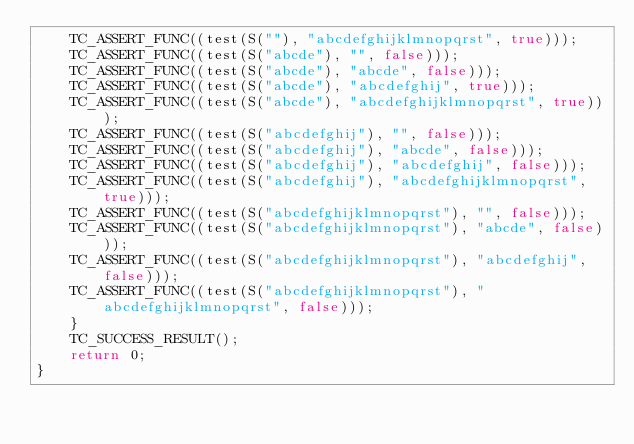<code> <loc_0><loc_0><loc_500><loc_500><_C++_>    TC_ASSERT_FUNC((test(S(""), "abcdefghijklmnopqrst", true)));
    TC_ASSERT_FUNC((test(S("abcde"), "", false)));
    TC_ASSERT_FUNC((test(S("abcde"), "abcde", false)));
    TC_ASSERT_FUNC((test(S("abcde"), "abcdefghij", true)));
    TC_ASSERT_FUNC((test(S("abcde"), "abcdefghijklmnopqrst", true)));
    TC_ASSERT_FUNC((test(S("abcdefghij"), "", false)));
    TC_ASSERT_FUNC((test(S("abcdefghij"), "abcde", false)));
    TC_ASSERT_FUNC((test(S("abcdefghij"), "abcdefghij", false)));
    TC_ASSERT_FUNC((test(S("abcdefghij"), "abcdefghijklmnopqrst", true)));
    TC_ASSERT_FUNC((test(S("abcdefghijklmnopqrst"), "", false)));
    TC_ASSERT_FUNC((test(S("abcdefghijklmnopqrst"), "abcde", false)));
    TC_ASSERT_FUNC((test(S("abcdefghijklmnopqrst"), "abcdefghij", false)));
    TC_ASSERT_FUNC((test(S("abcdefghijklmnopqrst"), "abcdefghijklmnopqrst", false)));
    }
    TC_SUCCESS_RESULT();
    return 0;
}
</code> 